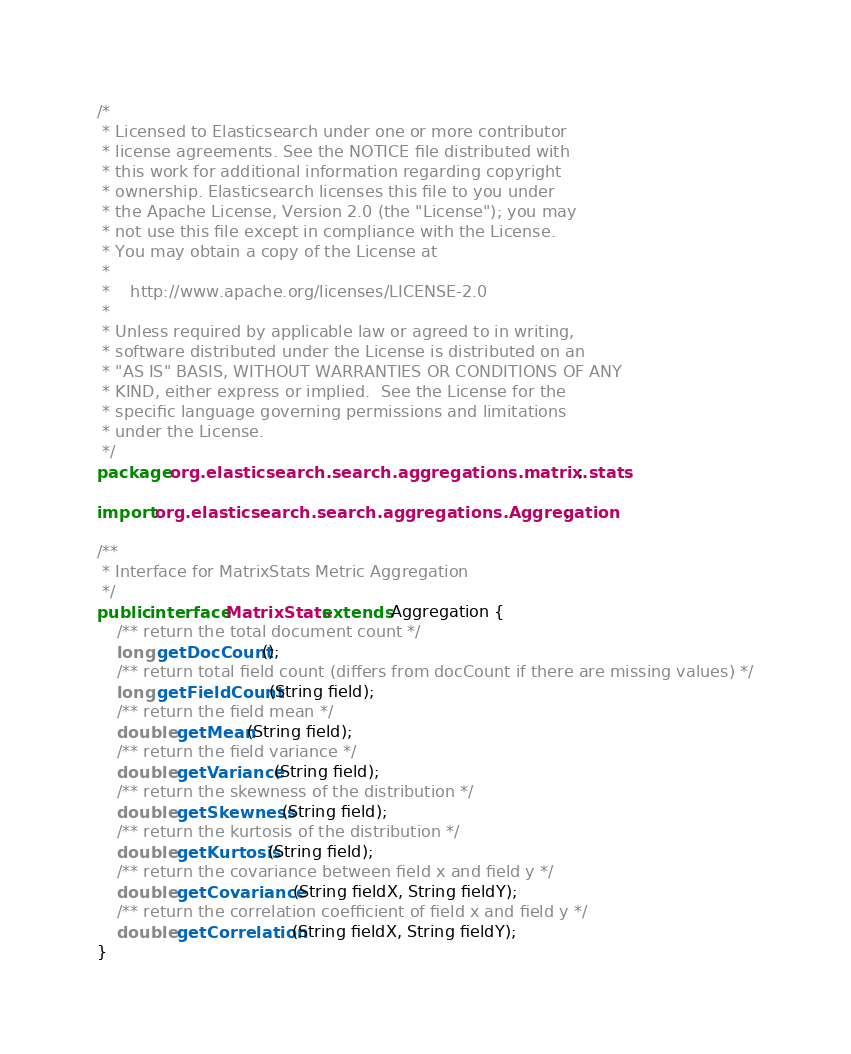<code> <loc_0><loc_0><loc_500><loc_500><_Java_>/*
 * Licensed to Elasticsearch under one or more contributor
 * license agreements. See the NOTICE file distributed with
 * this work for additional information regarding copyright
 * ownership. Elasticsearch licenses this file to you under
 * the Apache License, Version 2.0 (the "License"); you may
 * not use this file except in compliance with the License.
 * You may obtain a copy of the License at
 *
 *    http://www.apache.org/licenses/LICENSE-2.0
 *
 * Unless required by applicable law or agreed to in writing,
 * software distributed under the License is distributed on an
 * "AS IS" BASIS, WITHOUT WARRANTIES OR CONDITIONS OF ANY
 * KIND, either express or implied.  See the License for the
 * specific language governing permissions and limitations
 * under the License.
 */
package org.elasticsearch.search.aggregations.matrix.stats;

import org.elasticsearch.search.aggregations.Aggregation;

/**
 * Interface for MatrixStats Metric Aggregation
 */
public interface MatrixStats extends Aggregation {
    /** return the total document count */
    long getDocCount();
    /** return total field count (differs from docCount if there are missing values) */
    long getFieldCount(String field);
    /** return the field mean */
    double getMean(String field);
    /** return the field variance */
    double getVariance(String field);
    /** return the skewness of the distribution */
    double getSkewness(String field);
    /** return the kurtosis of the distribution */
    double getKurtosis(String field);
    /** return the covariance between field x and field y */
    double getCovariance(String fieldX, String fieldY);
    /** return the correlation coefficient of field x and field y */
    double getCorrelation(String fieldX, String fieldY);
}
</code> 